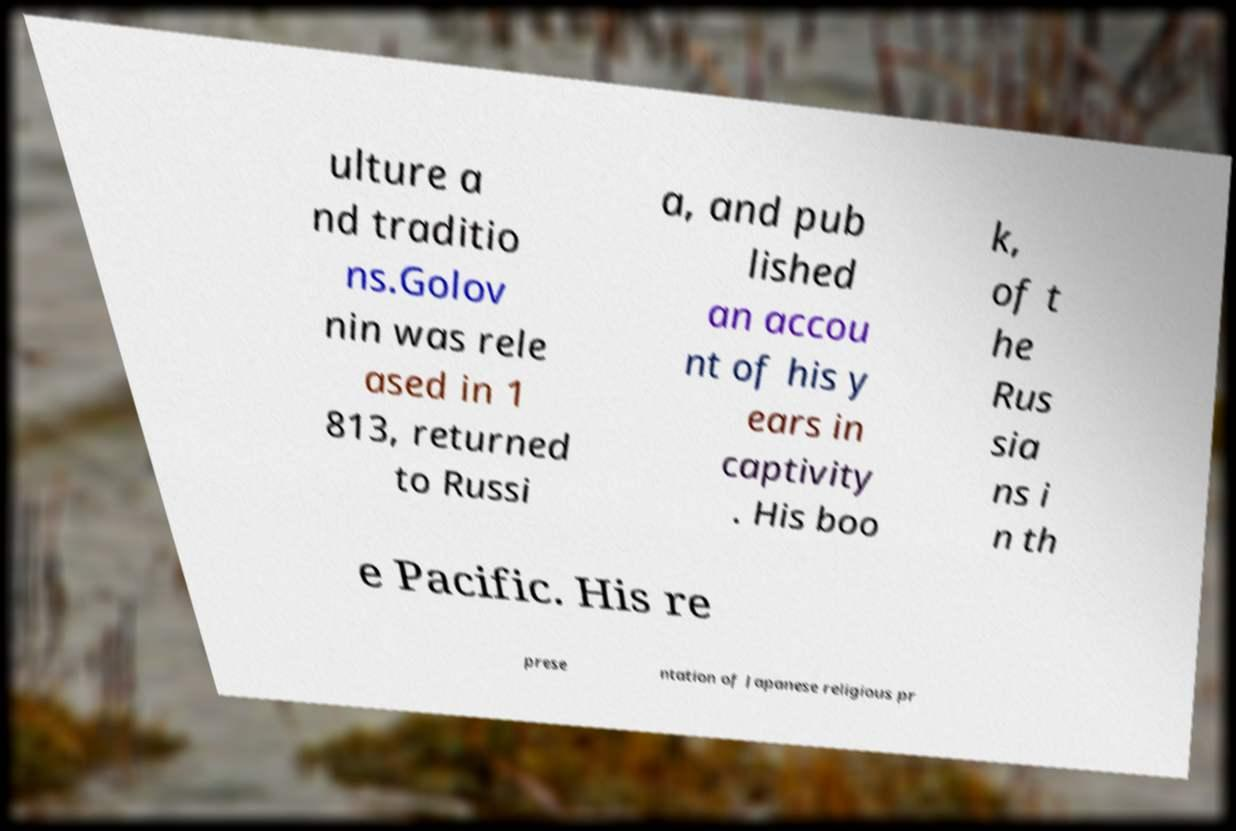Could you assist in decoding the text presented in this image and type it out clearly? ulture a nd traditio ns.Golov nin was rele ased in 1 813, returned to Russi a, and pub lished an accou nt of his y ears in captivity . His boo k, of t he Rus sia ns i n th e Pacific. His re prese ntation of Japanese religious pr 